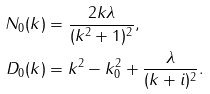<formula> <loc_0><loc_0><loc_500><loc_500>N _ { 0 } ( k ) & = \frac { 2 k \lambda } { ( k ^ { 2 } + 1 ) ^ { 2 } } , \\ D _ { 0 } ( k ) & = k ^ { 2 } - k _ { 0 } ^ { 2 } + \frac { \lambda } { ( k + i ) ^ { 2 } } .</formula> 